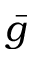<formula> <loc_0><loc_0><loc_500><loc_500>\bar { g }</formula> 